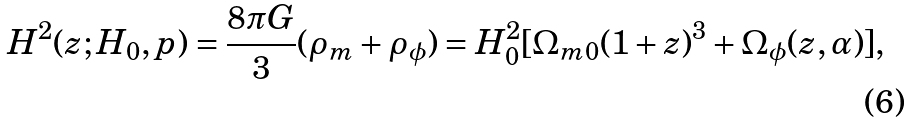<formula> <loc_0><loc_0><loc_500><loc_500>H ^ { 2 } ( z ; H _ { 0 } , p ) = \frac { 8 \pi G } { 3 } ( \rho _ { m } + \rho _ { \phi } ) = H _ { 0 } ^ { 2 } [ \Omega _ { m 0 } ( 1 + z ) ^ { 3 } + \Omega _ { \phi } ( z , \alpha ) ] ,</formula> 